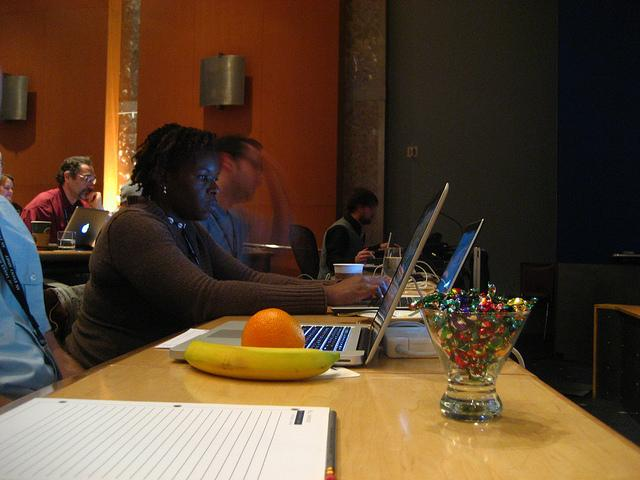Which food is the most unhealthy? candy 